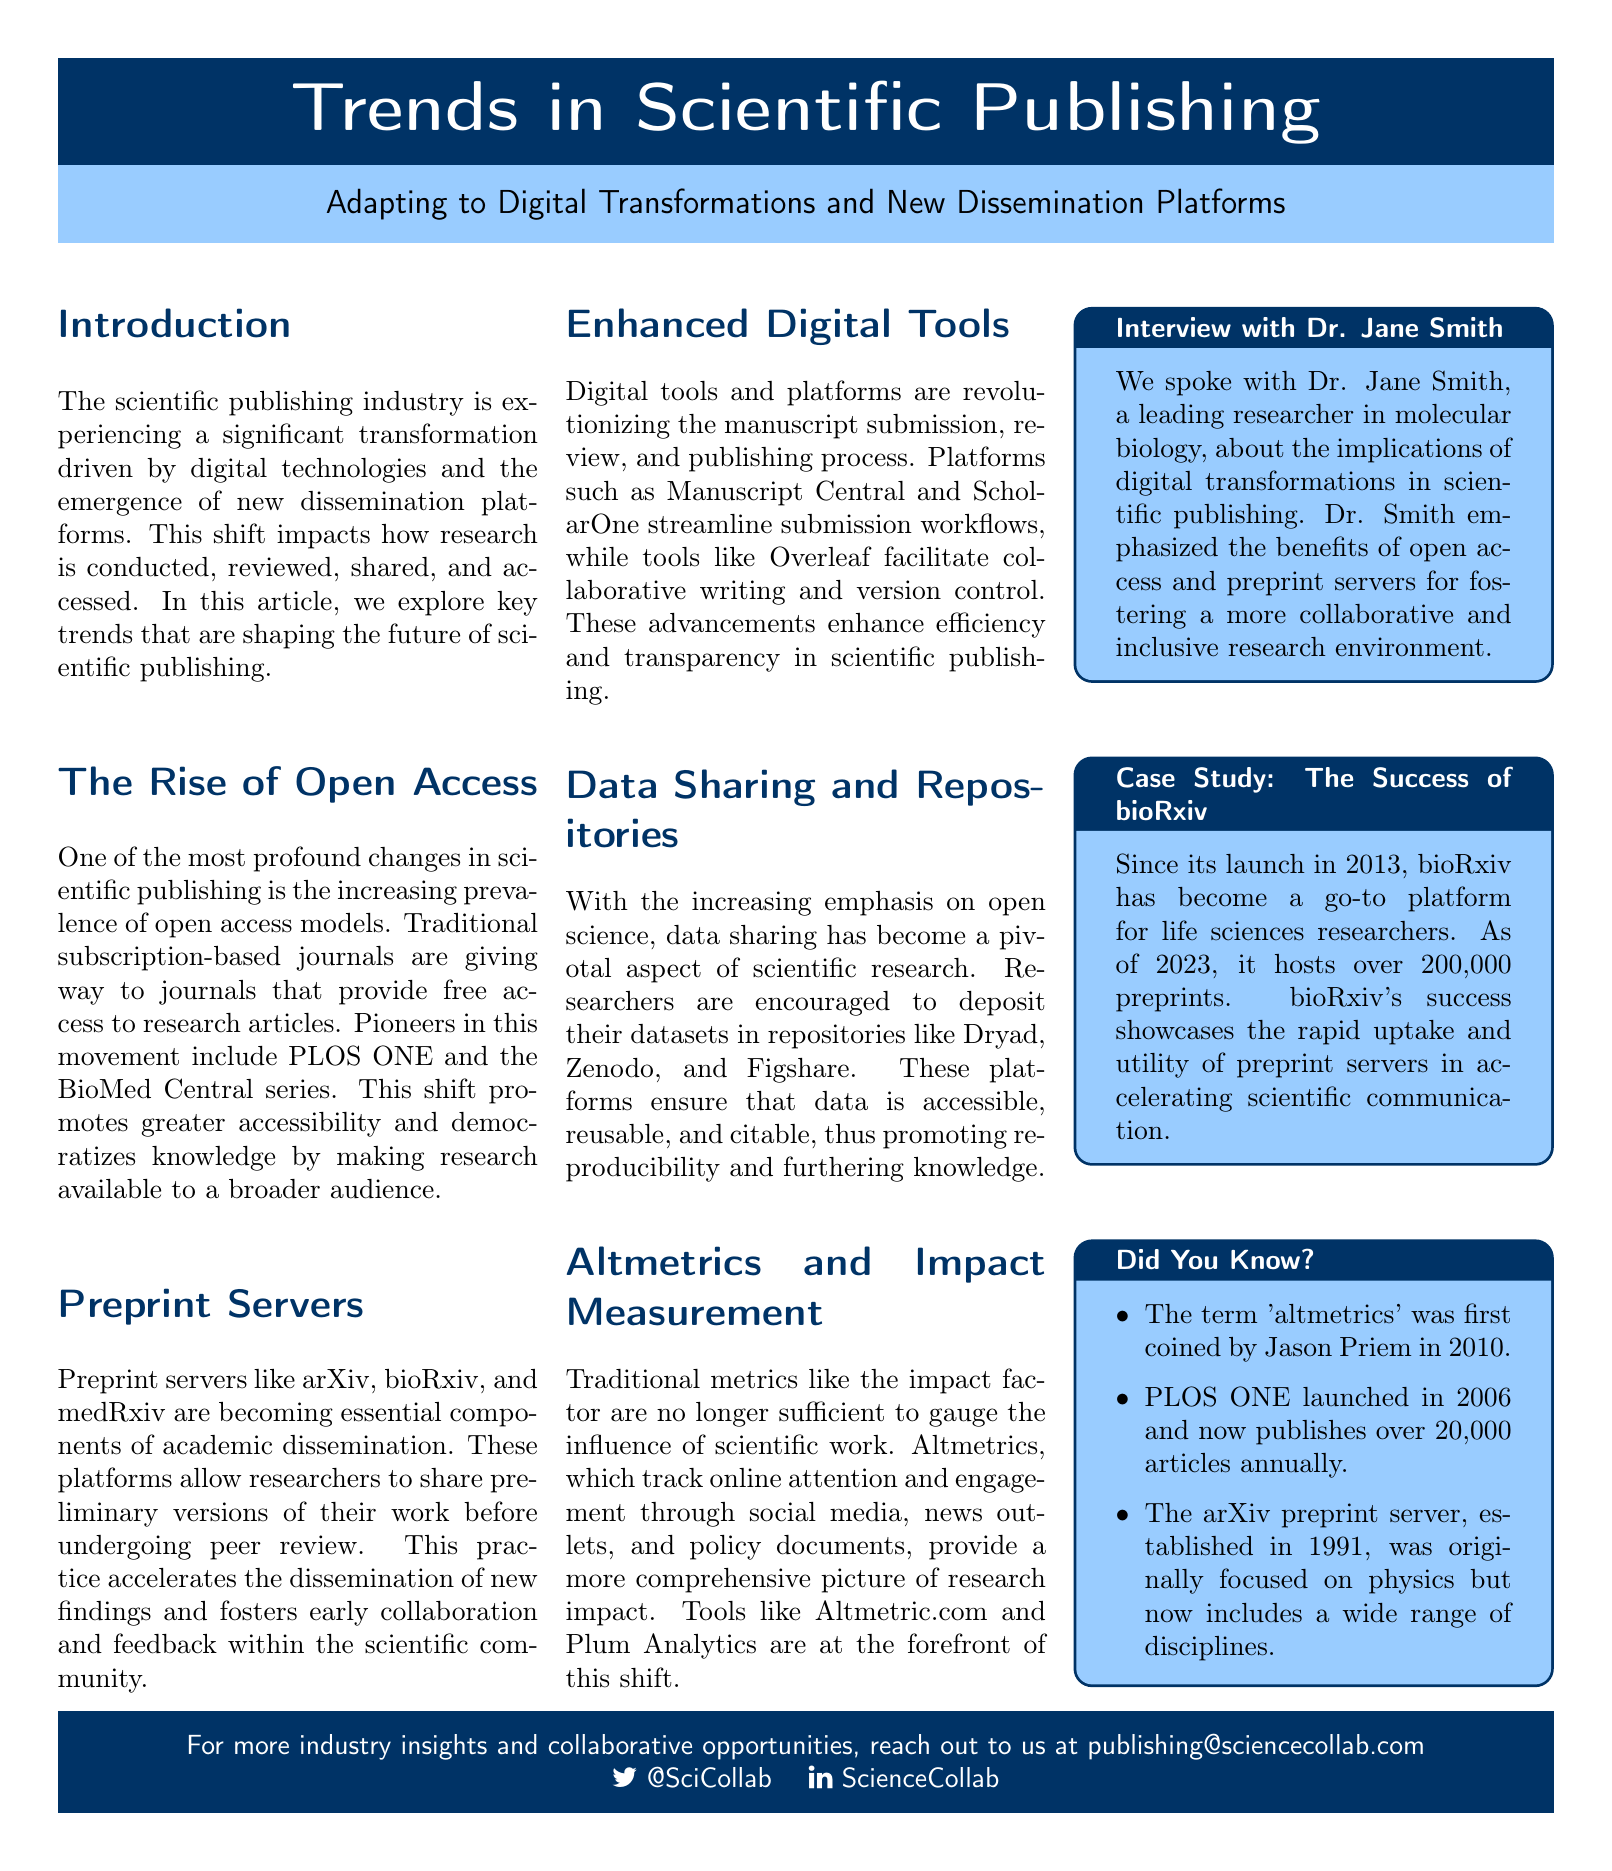What is the title of the article? The title is prominently displayed at the top of the document, indicating the main topic discussed.
Answer: Trends in Scientific Publishing What platforms are mentioned as preprint servers? The document lists specific preprint servers that are commonly used by researchers.
Answer: arXiv, bioRxiv, medRxiv What year did bioRxiv launch? The case study section notes the founding year of bioRxiv.
Answer: 2013 How many articles does PLOS ONE publish annually? The document provides a specific number regarding the publication output of PLOS ONE.
Answer: Over 20,000 What is the primary benefit of open access according to Dr. Jane Smith? This benefit is implied through her emphasis in the interview section of the document.
Answer: Collaboration Which term was first coined in 2010? This fact is mentioned in the "Did You Know?" section, providing insight into the history of research metrics.
Answer: Altmetrics What do traditional metrics like impact factor measure? This question touches on what traditional metrics are used for, as mentioned in the context of shifting measurement standards.
Answer: Research influence How many preprints does bioRxiv host as of 2023? The case study details the current reach of bioRxiv in terms of preprints available.
Answer: Over 200,000 